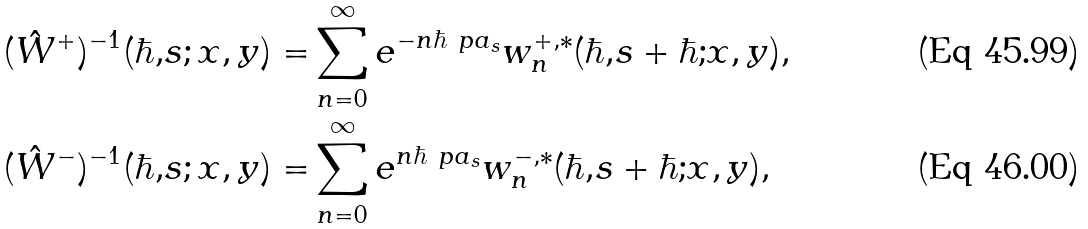Convert formula to latex. <formula><loc_0><loc_0><loc_500><loc_500>( \hat { W } ^ { + } ) ^ { - 1 } ( \hbar { , } s ; x , y ) = & \sum _ { n = 0 } ^ { \infty } e ^ { - n \hbar { \ } p a _ { s } } w _ { n } ^ { + , * } ( \hbar { , } s + \hbar { ; } x , y ) , \\ ( \hat { W } ^ { - } ) ^ { - 1 } ( \hbar { , } s ; x , y ) = & \sum _ { n = 0 } ^ { \infty } e ^ { n \hbar { \ } p a _ { s } } w _ { n } ^ { - , * } ( \hbar { , } s + \hbar { ; } x , y ) ,</formula> 